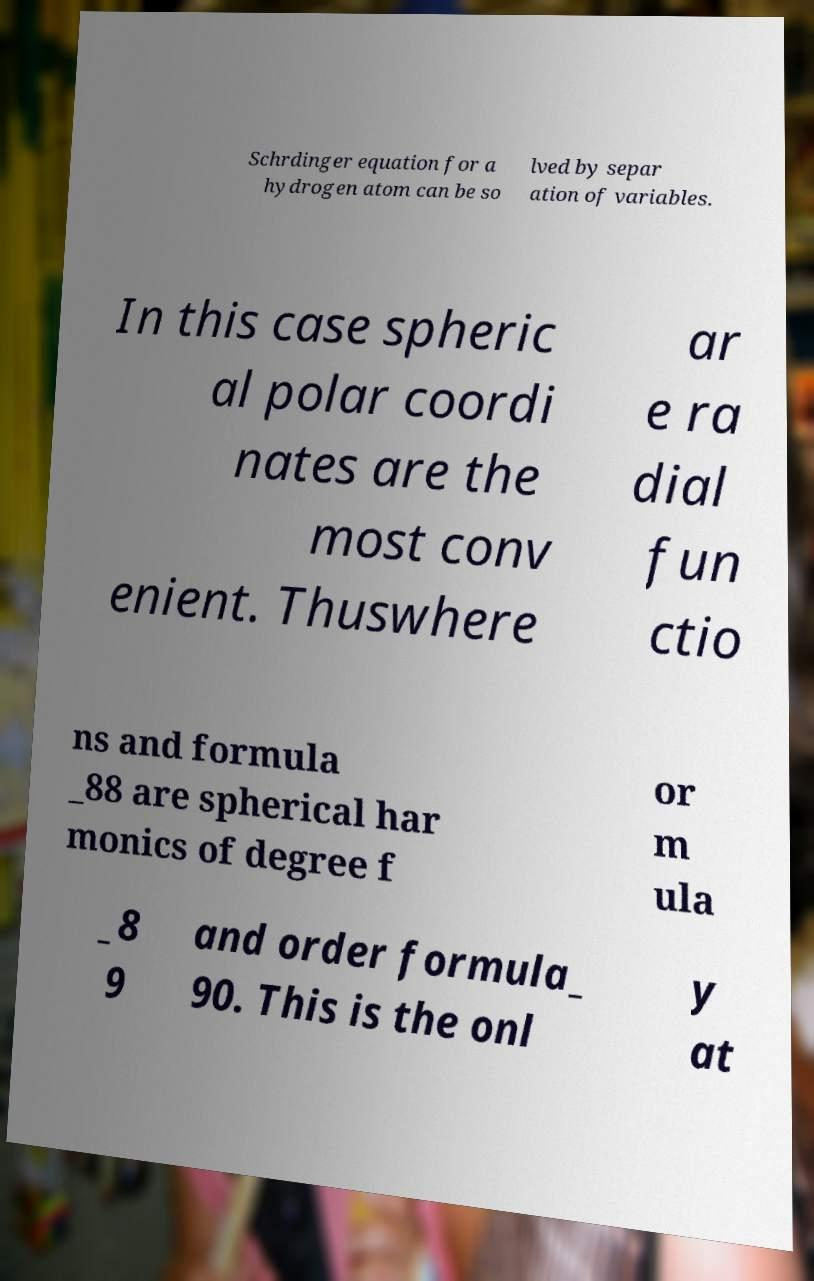Could you assist in decoding the text presented in this image and type it out clearly? Schrdinger equation for a hydrogen atom can be so lved by separ ation of variables. In this case spheric al polar coordi nates are the most conv enient. Thuswhere ar e ra dial fun ctio ns and formula _88 are spherical har monics of degree f or m ula _8 9 and order formula_ 90. This is the onl y at 